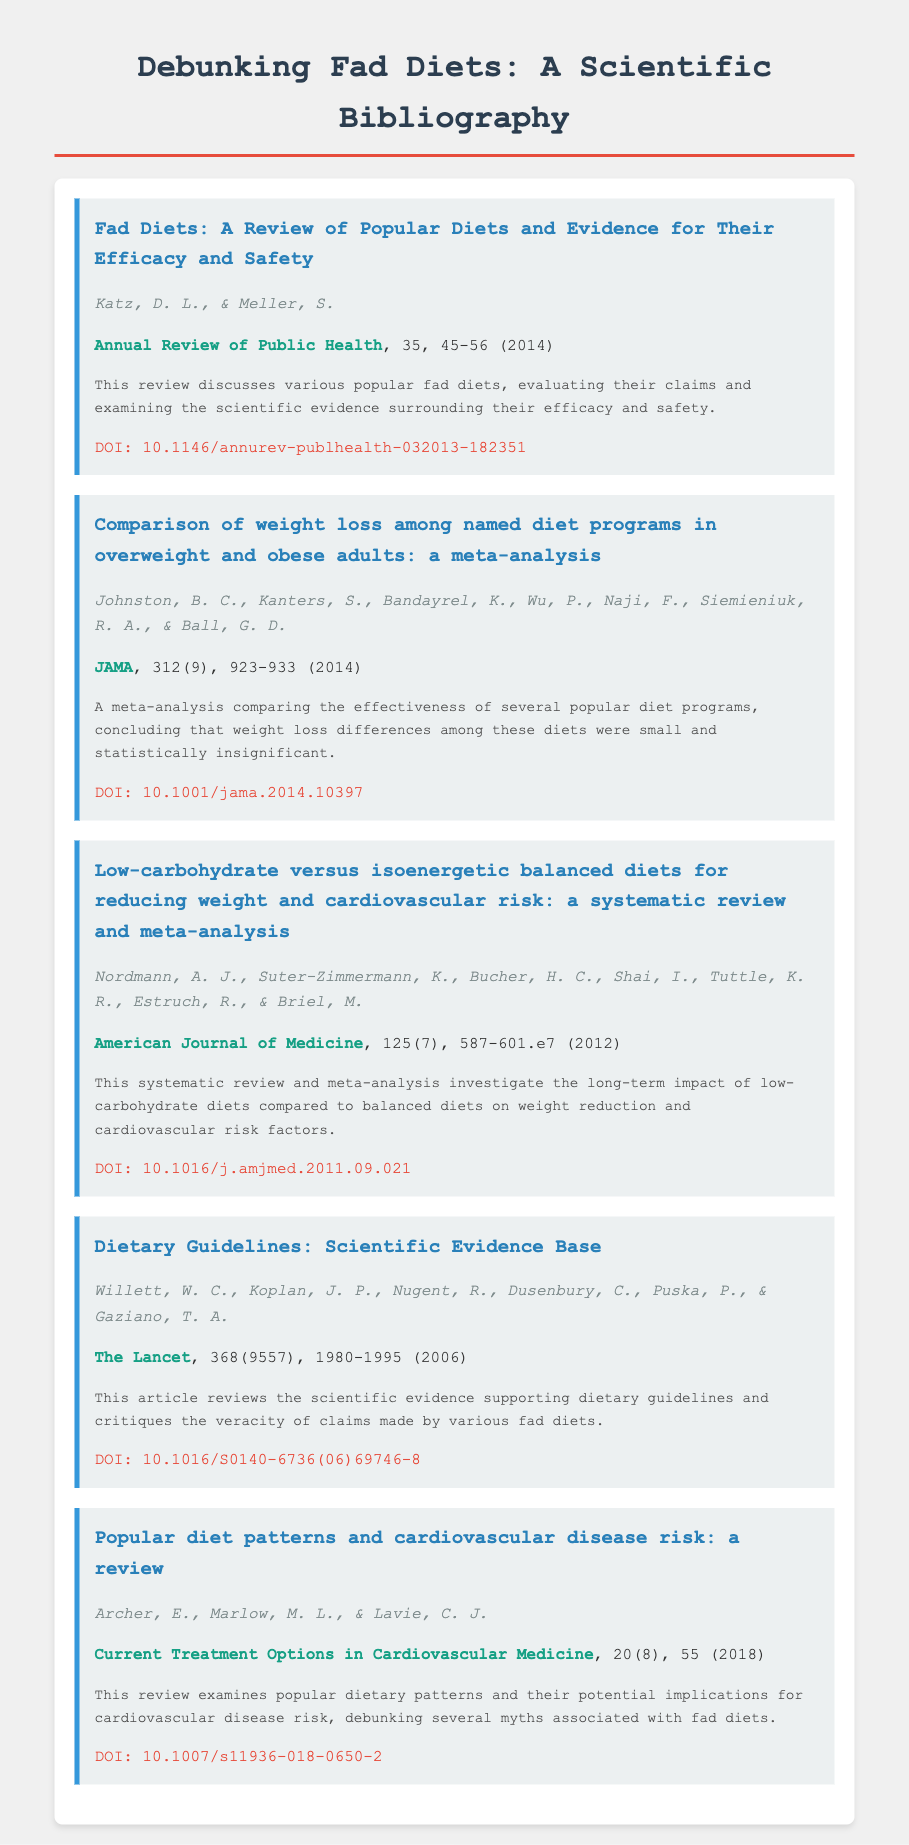what is the title of the first entry? The title of the first entry provides an overview of the review on fad diets.
Answer: Fad Diets: A Review of Popular Diets and Evidence for Their Efficacy and Safety who are the authors of the second entry? The authors of the second entry are listed directly under the title and are critical for understanding the research credibility.
Answer: Johnston, B. C., Kanters, S., Bandayrel, K., Wu, P., Naji, F., Siemieniuk, R. A., & Ball, G. D what is the journal name for the fourth entry? The journal name indicates the publication source of the fourth entry, which is essential for academic referencing.
Answer: The Lancet how many studies are cited in total in the bibliography? The number of entries in the bibliography gives an idea of the breadth of research included.
Answer: 5 what conclusion does the meta-analysis in the second entry reach about weight loss? This conclusion summarizes the findings of the study regarding the effectiveness of different diets.
Answer: Small and statistically insignificant which year was the systematic review in the third entry published? The publication year is important for contextualizing the relevance of the research.
Answer: 2012 what is the DOI of the last entry? The DOI is a unique identifier for the digital version of the article, crucial for locating the source.
Answer: 10.1007/s11936-018-0650-2 which entry discusses dietary guidelines? Identifying the entry that deals with dietary guidelines helps highlight its importance in the context of fad diets.
Answer: Dietary Guidelines: Scientific Evidence Base what is the publication year of the review in the fifth entry? Knowing the publication year of the review allows one to assess the timeliness of the findings.
Answer: 2018 